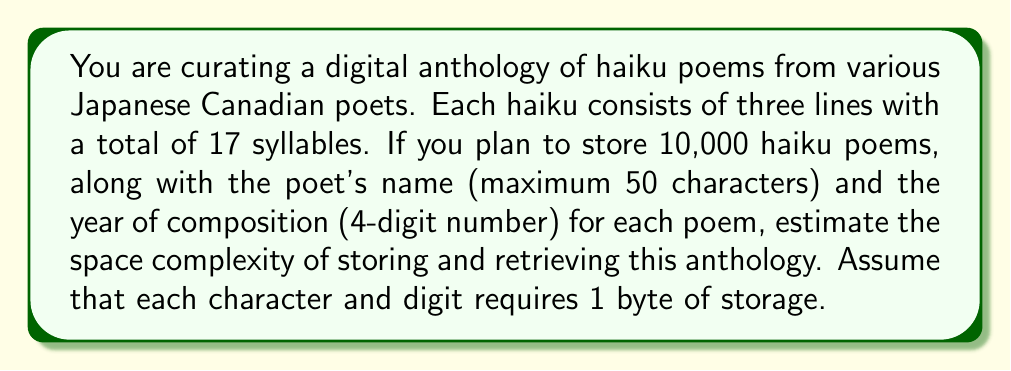Give your solution to this math problem. Let's break down the space complexity analysis step by step:

1. Storage for each haiku:
   - Each haiku has 3 lines with a total of 17 syllables.
   - Assuming an average of 5 characters per syllable (including spaces and punctuation):
     17 syllables × 5 characters/syllable = 85 characters
   - Space required for haiku text: 85 bytes

2. Storage for poet's name:
   - Maximum 50 characters = 50 bytes

3. Storage for year of composition:
   - 4-digit number = 4 bytes

4. Total storage for one haiku entry:
   $S_{entry} = 85 + 50 + 4 = 139$ bytes

5. Total storage for 10,000 haiku entries:
   $S_{total} = 10,000 \times 139 = 1,390,000$ bytes

6. Additional storage considerations:
   - We may need indexing structures for efficient retrieval, such as a hash table or search tree.
   - Let's assume an overhead of 20% for indexing:
     $S_{indexing} = 0.2 \times 1,390,000 = 278,000$ bytes

7. Final space complexity:
   $S_{final} = S_{total} + S_{indexing} = 1,390,000 + 278,000 = 1,668,000$ bytes

The space complexity can be expressed as $O(n)$, where $n$ is the number of haiku poems, since the storage required grows linearly with the number of poems.
Answer: The estimated space complexity for storing and retrieving 10,000 haiku poems in the digital anthology is $O(n)$, with approximately 1,668,000 bytes (or about 1.67 MB) of storage required. 